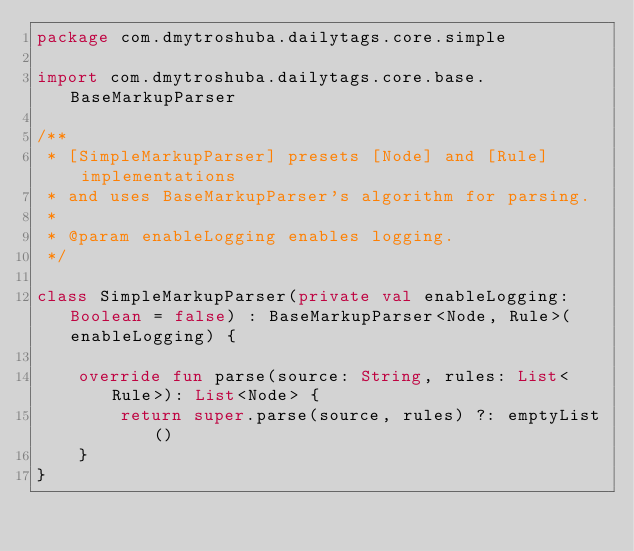Convert code to text. <code><loc_0><loc_0><loc_500><loc_500><_Kotlin_>package com.dmytroshuba.dailytags.core.simple

import com.dmytroshuba.dailytags.core.base.BaseMarkupParser

/**
 * [SimpleMarkupParser] presets [Node] and [Rule] implementations
 * and uses BaseMarkupParser's algorithm for parsing.
 *
 * @param enableLogging enables logging.
 */

class SimpleMarkupParser(private val enableLogging: Boolean = false) : BaseMarkupParser<Node, Rule>(enableLogging) {

    override fun parse(source: String, rules: List<Rule>): List<Node> {
        return super.parse(source, rules) ?: emptyList()
    }
}</code> 